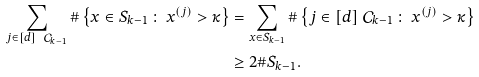Convert formula to latex. <formula><loc_0><loc_0><loc_500><loc_500>\sum _ { j \in [ d ] \ \mathcal { C } _ { k - 1 } } \# \left \{ x \in S _ { k - 1 } \, \colon \, x ^ { ( j ) } > \kappa \right \} & = \sum _ { x \in S _ { k - 1 } } \# \left \{ j \in [ d ] \ \mathcal { C } _ { k - 1 } \, \colon \, x ^ { ( j ) } > \kappa \right \} \\ & \geq 2 \# S _ { k - 1 } .</formula> 